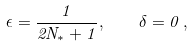<formula> <loc_0><loc_0><loc_500><loc_500>\epsilon = \frac { 1 } { 2 N _ { * } + 1 } , \quad \delta = 0 \, ,</formula> 